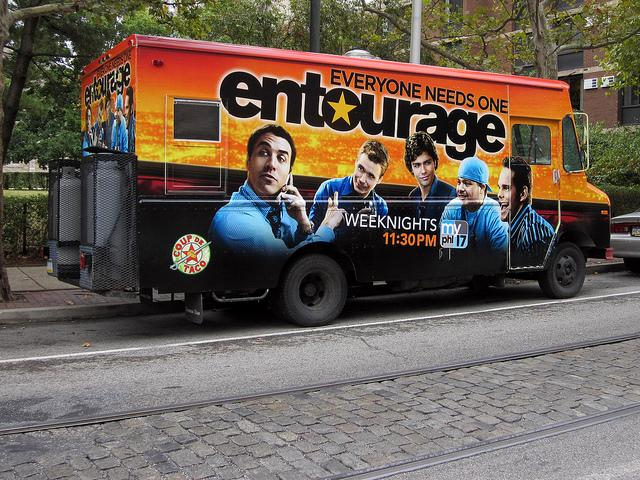Why does the van have a realistic photo on the side? advertisement 